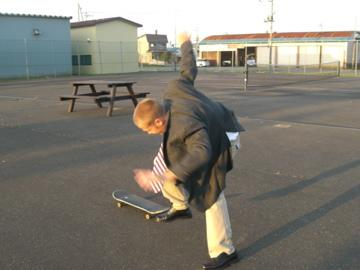What is happening with the skateboard in the image? A man is falling off a black skateboard with yellow wheels on the ground. Describe the buildings in the background of the image. There are white, yellow, and blue buildings in the distance. Please tell me about the tie the man is wearing. The man is wearing a striped red and white necktie. Which action is the young boy performing? The young boy is stomping the ground. What kind of pants is the man wearing? The man is wearing a pair of mens tan (khaki) pants. What type of wheels are on the skateboard? The skateboard has yellow wheels. Identify the color and style of the man's hair in the image. The man has short blonde-colored hair with a brush cut. What kind of fence is featured in the image? A tall chain link fence is in the image. Describe what the person in the image is wearing on their feet. The person is wearing shiny black dress shoes. Can you please describe the table present in the picture? There is an empty wooden picnic bench in the background. 